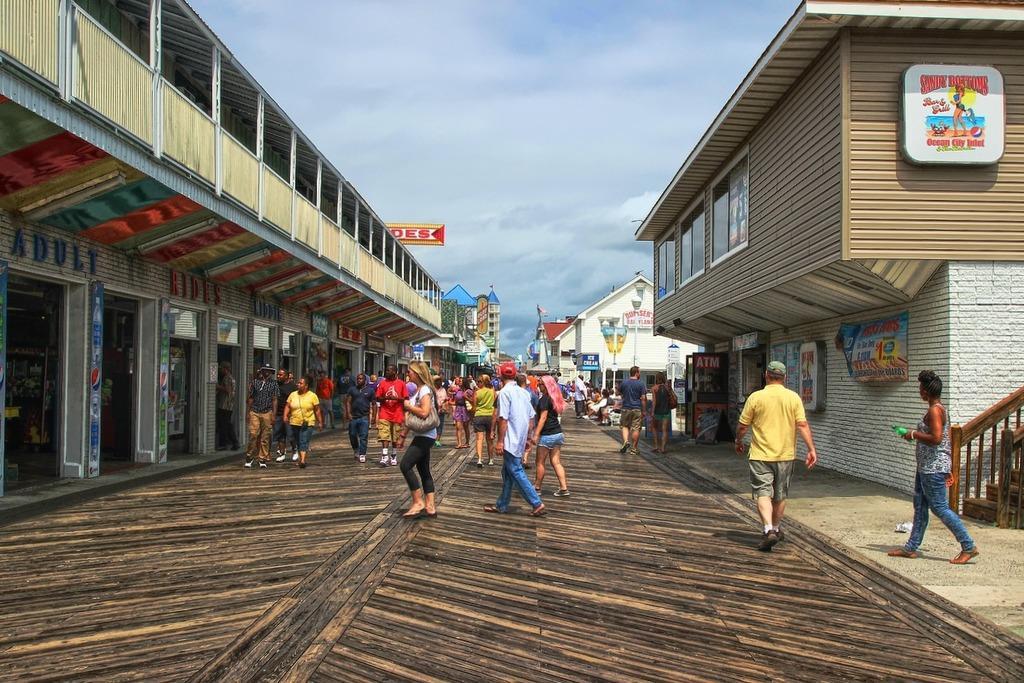Can you describe this image briefly? In this image we can see a few buildings and board with some text and images, there are some people, among them some people are sitting on the chairs, also we can see poles, lights, stair case and the sky with clouds. 